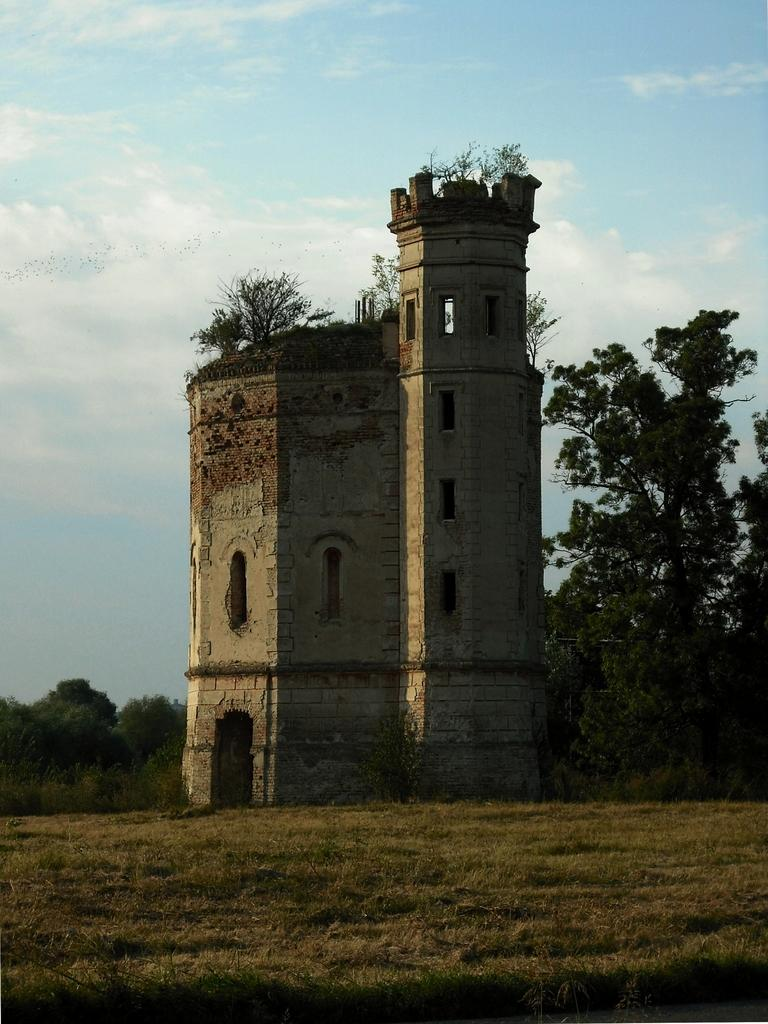What type of structure is in the image? There is a fort in the image. What features can be seen on the fort? The fort has walls and windows. What type of vegetation is present in the image? There are plants, trees, and grass in the image. What can be seen in the background of the image? The sky is visible in the background of the image. How many cacti are present in the image? There are no cacti visible in the image. What type of ornament is hanging from the fort's walls? There is no ornament hanging from the fort's walls in the image. 